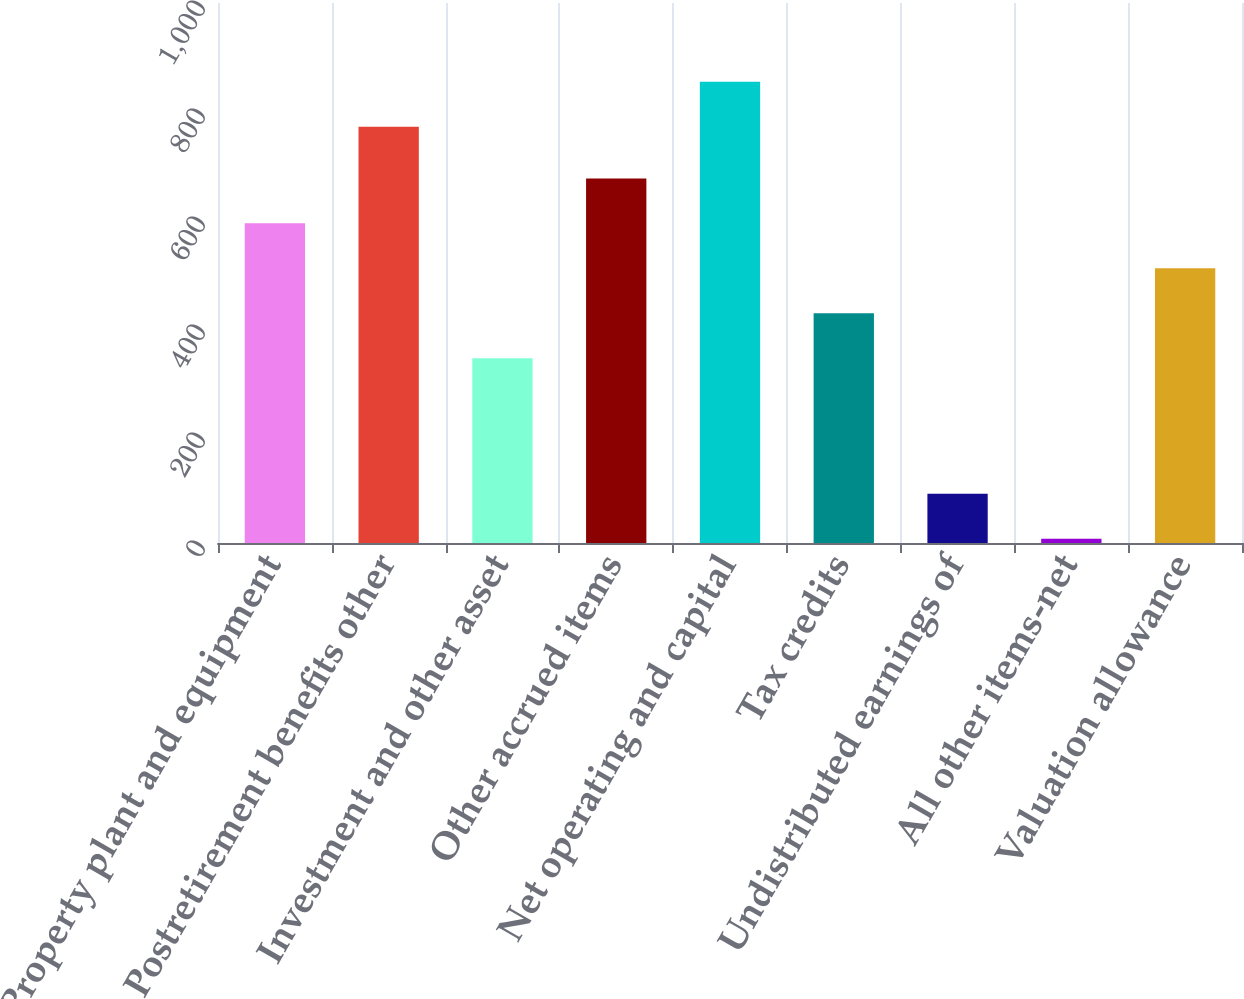Convert chart to OTSL. <chart><loc_0><loc_0><loc_500><loc_500><bar_chart><fcel>Property plant and equipment<fcel>Postretirement benefits other<fcel>Investment and other asset<fcel>Other accrued items<fcel>Net operating and capital<fcel>Tax credits<fcel>Undistributed earnings of<fcel>All other items-net<fcel>Valuation allowance<nl><fcel>591.9<fcel>771<fcel>342<fcel>675.2<fcel>854.3<fcel>425.3<fcel>91.3<fcel>8<fcel>508.6<nl></chart> 